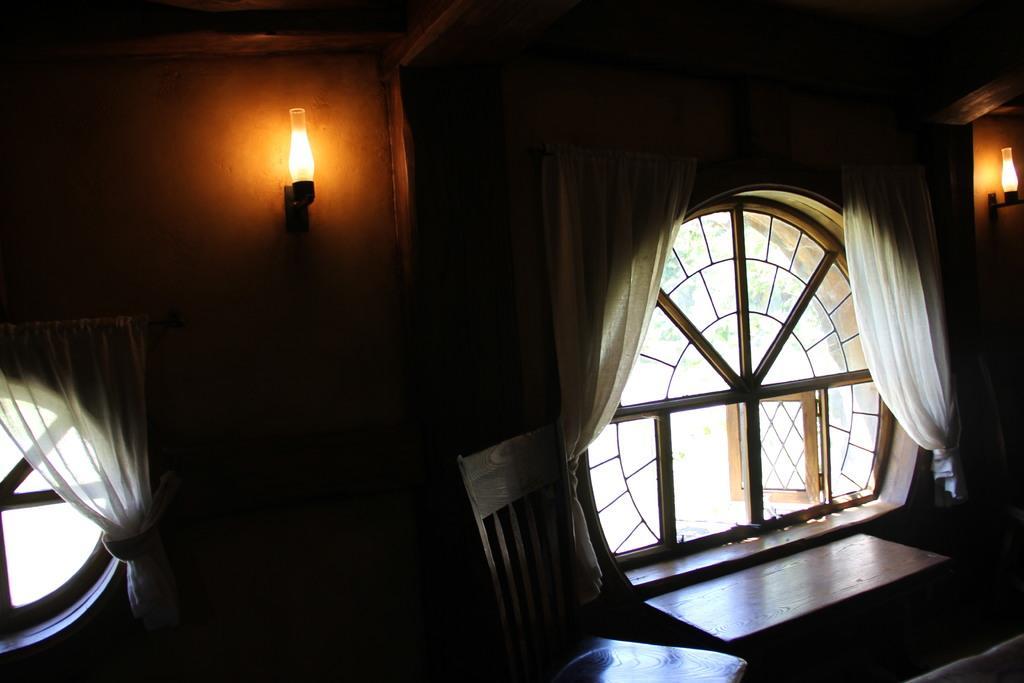Please provide a concise description of this image. In this picture we can see the inside view of the room. On the top left there is a light. On the left and right side we can see the windows. Through the window we can see the plants. At the bottom we can see the wooden table and chairs. Beside that we can see the window cloth. 